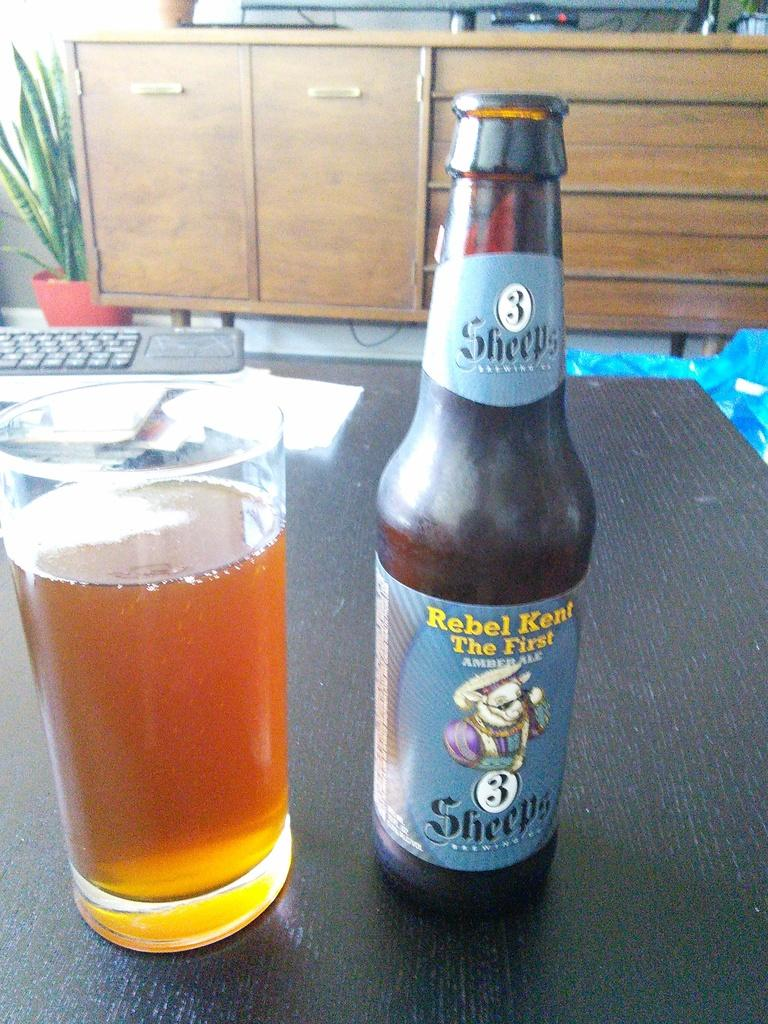<image>
Provide a brief description of the given image. Bottle of Rebel Kent The First with a blue label next to a full cup of beer. 